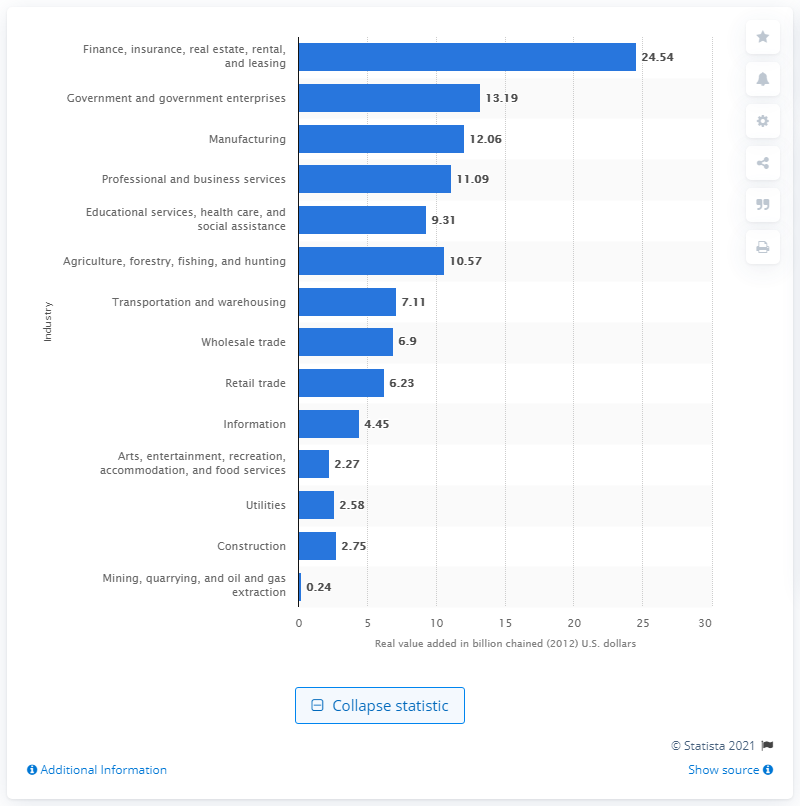Identify some key points in this picture. In 2012, the finance, insurance, real estate, rental, and leasing industry contributed 24.54% to Nebraska's gross domestic product. 